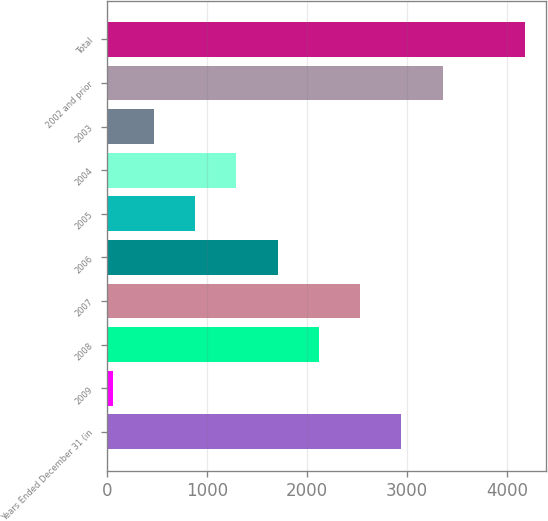Convert chart. <chart><loc_0><loc_0><loc_500><loc_500><bar_chart><fcel>Years Ended December 31 (in<fcel>2009<fcel>2008<fcel>2007<fcel>2006<fcel>2005<fcel>2004<fcel>2003<fcel>2002 and prior<fcel>Total<nl><fcel>2945.7<fcel>61<fcel>2121.5<fcel>2533.6<fcel>1709.4<fcel>885.2<fcel>1297.3<fcel>473.1<fcel>3357.8<fcel>4182<nl></chart> 